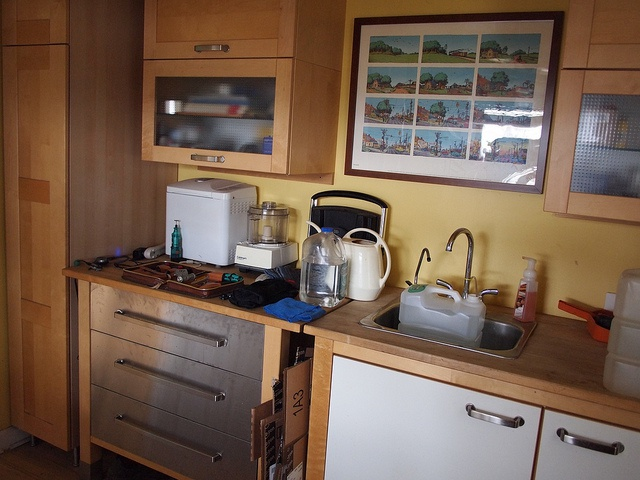Describe the objects in this image and their specific colors. I can see sink in black, maroon, and gray tones, bottle in black, gray, darkgray, and lightgray tones, bottle in black, maroon, gray, and brown tones, and bottle in black, teal, darkgray, and gray tones in this image. 